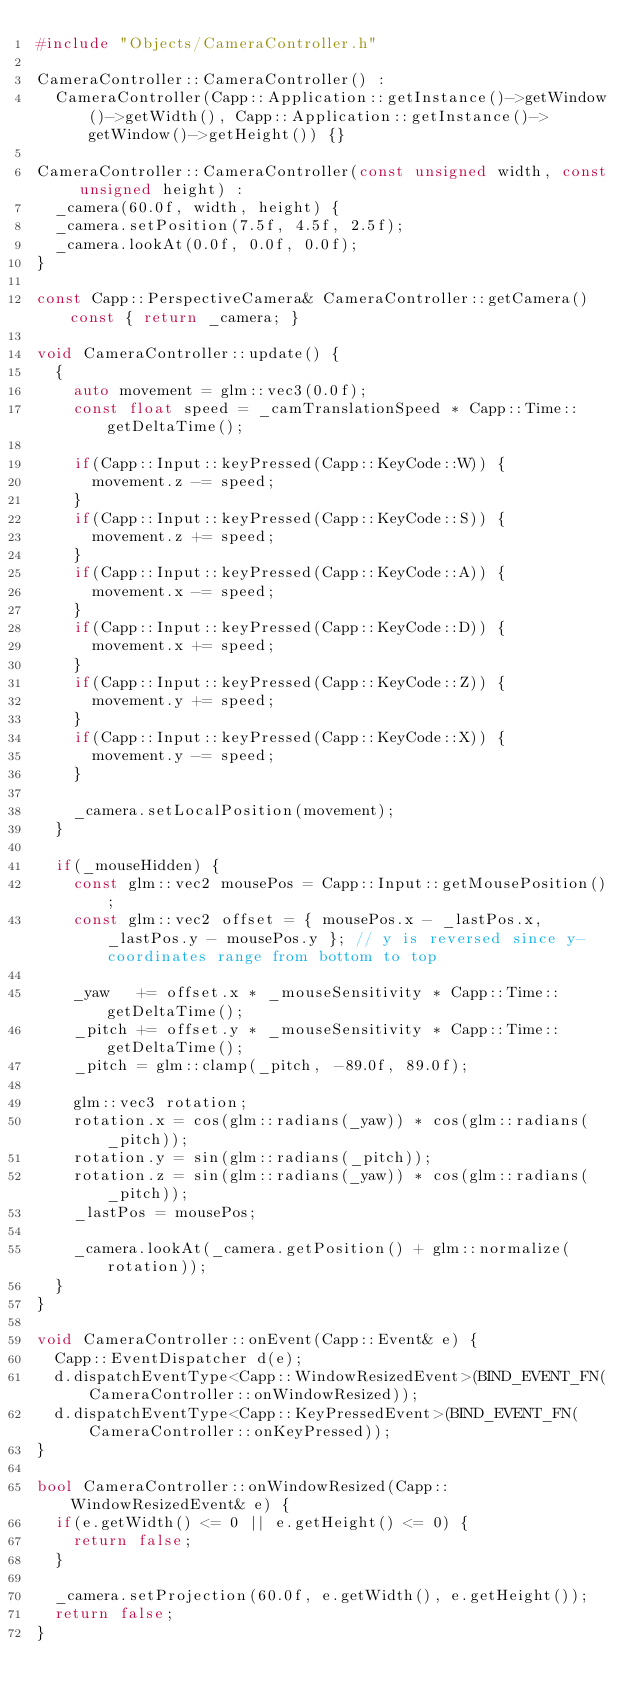Convert code to text. <code><loc_0><loc_0><loc_500><loc_500><_C++_>#include "Objects/CameraController.h"

CameraController::CameraController() :
	CameraController(Capp::Application::getInstance()->getWindow()->getWidth(), Capp::Application::getInstance()->getWindow()->getHeight()) {}

CameraController::CameraController(const unsigned width, const unsigned height) :
	_camera(60.0f, width, height) {
	_camera.setPosition(7.5f, 4.5f, 2.5f);
	_camera.lookAt(0.0f, 0.0f, 0.0f);
}

const Capp::PerspectiveCamera& CameraController::getCamera() const { return _camera; }

void CameraController::update() {
	{
		auto movement = glm::vec3(0.0f);
		const float speed = _camTranslationSpeed * Capp::Time::getDeltaTime();
		
		if(Capp::Input::keyPressed(Capp::KeyCode::W)) {
			movement.z -= speed;
		}
		if(Capp::Input::keyPressed(Capp::KeyCode::S)) {
			movement.z += speed;
		}
		if(Capp::Input::keyPressed(Capp::KeyCode::A)) {
			movement.x -= speed;
		}
		if(Capp::Input::keyPressed(Capp::KeyCode::D)) {
			movement.x += speed;
		}
		if(Capp::Input::keyPressed(Capp::KeyCode::Z)) {
			movement.y += speed;
		}
		if(Capp::Input::keyPressed(Capp::KeyCode::X)) {
			movement.y -= speed;
		}
		
		_camera.setLocalPosition(movement);
	}
	
	if(_mouseHidden) {
		const glm::vec2 mousePos = Capp::Input::getMousePosition();
		const glm::vec2 offset = { mousePos.x - _lastPos.x, _lastPos.y - mousePos.y }; // y is reversed since y-coordinates range from bottom to top
	
		_yaw   += offset.x * _mouseSensitivity * Capp::Time::getDeltaTime();
		_pitch += offset.y * _mouseSensitivity * Capp::Time::getDeltaTime();
		_pitch = glm::clamp(_pitch, -89.0f, 89.0f);

		glm::vec3 rotation;
		rotation.x = cos(glm::radians(_yaw)) * cos(glm::radians(_pitch));
		rotation.y = sin(glm::radians(_pitch));
		rotation.z = sin(glm::radians(_yaw)) * cos(glm::radians(_pitch));
		_lastPos = mousePos;
		
		_camera.lookAt(_camera.getPosition() + glm::normalize(rotation));
	}
}

void CameraController::onEvent(Capp::Event& e) {
	Capp::EventDispatcher d(e);
	d.dispatchEventType<Capp::WindowResizedEvent>(BIND_EVENT_FN(CameraController::onWindowResized));
	d.dispatchEventType<Capp::KeyPressedEvent>(BIND_EVENT_FN(CameraController::onKeyPressed));
}

bool CameraController::onWindowResized(Capp::WindowResizedEvent& e) {
	if(e.getWidth() <= 0 || e.getHeight() <= 0) {
		return false;
	}
	
	_camera.setProjection(60.0f, e.getWidth(), e.getHeight());
	return false;
}
</code> 